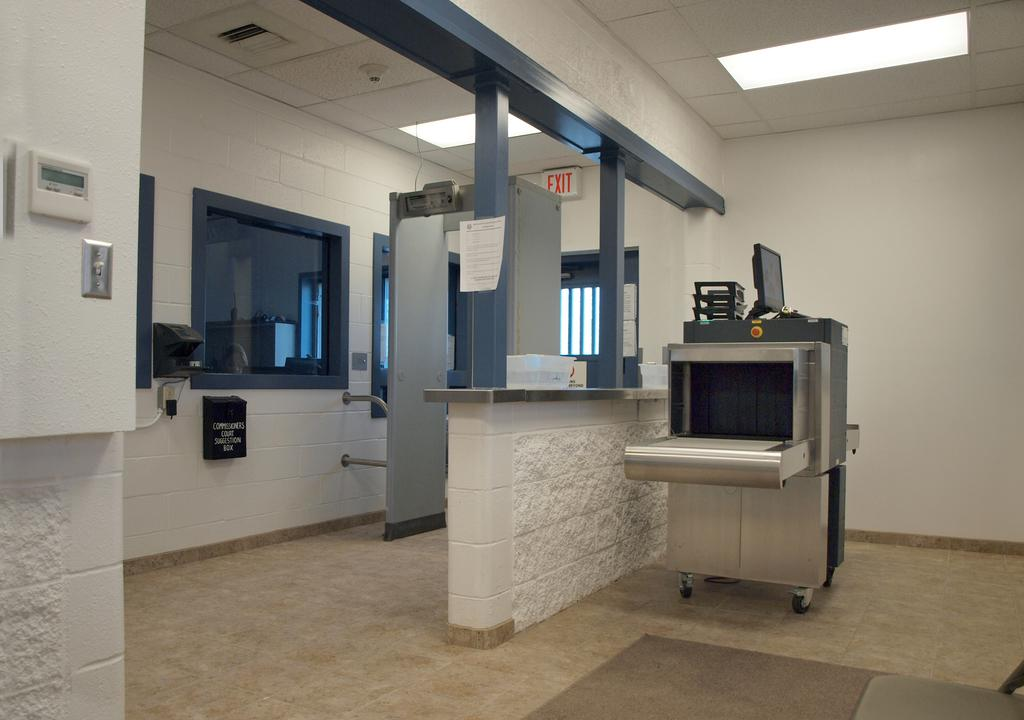<image>
Summarize the visual content of the image. Entrance to an office building with a suggestion box on the wall for the Commissioners Court. 